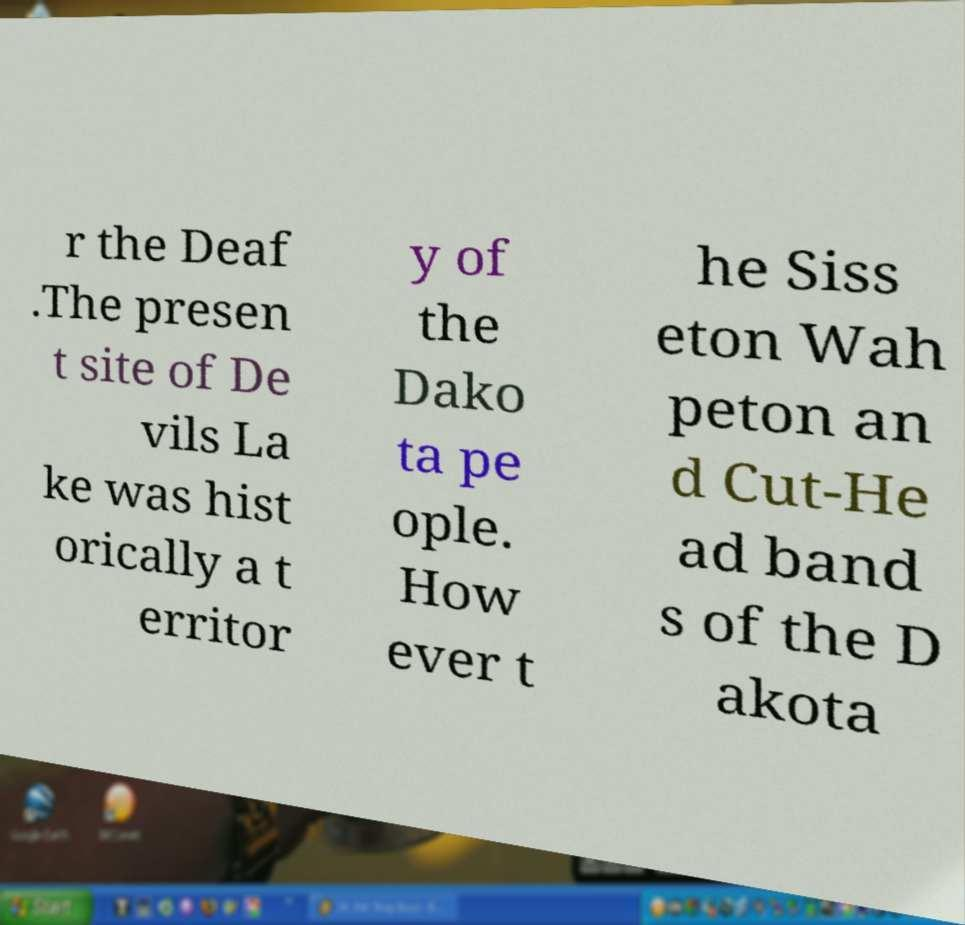What messages or text are displayed in this image? I need them in a readable, typed format. r the Deaf .The presen t site of De vils La ke was hist orically a t erritor y of the Dako ta pe ople. How ever t he Siss eton Wah peton an d Cut-He ad band s of the D akota 